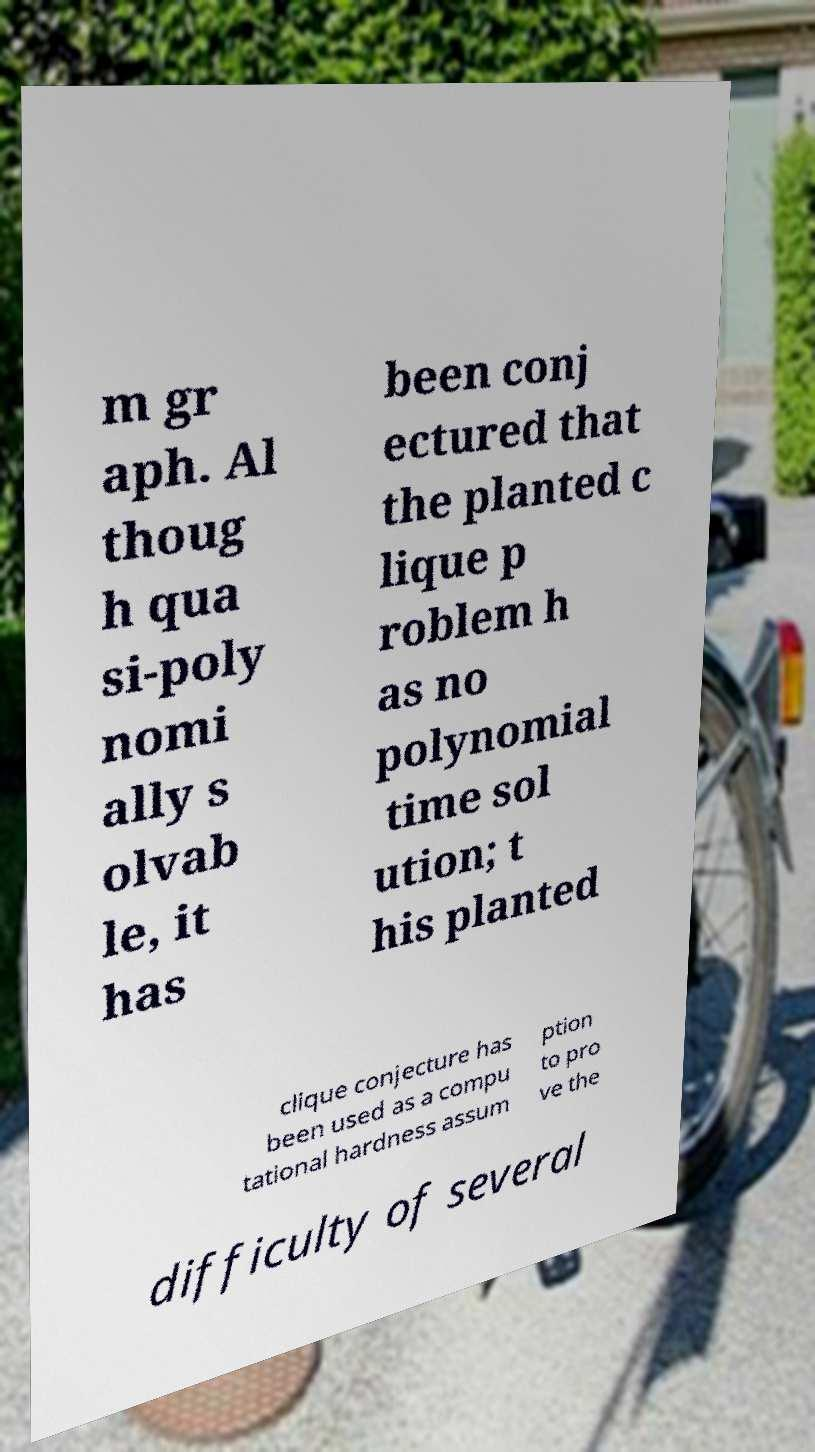Please read and relay the text visible in this image. What does it say? m gr aph. Al thoug h qua si-poly nomi ally s olvab le, it has been conj ectured that the planted c lique p roblem h as no polynomial time sol ution; t his planted clique conjecture has been used as a compu tational hardness assum ption to pro ve the difficulty of several 